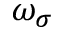<formula> <loc_0><loc_0><loc_500><loc_500>\omega _ { \sigma }</formula> 